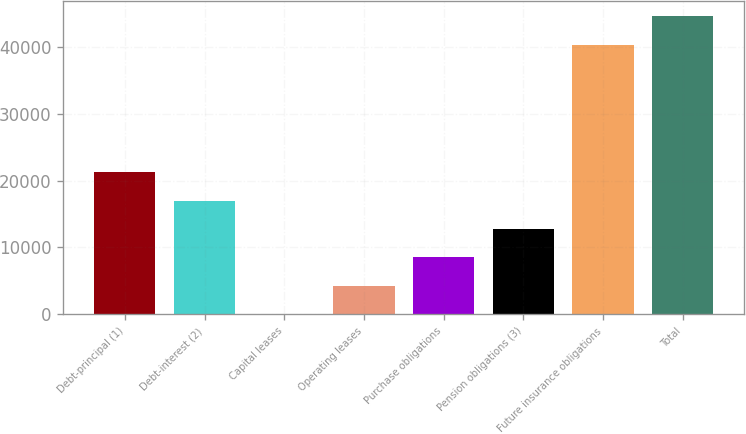<chart> <loc_0><loc_0><loc_500><loc_500><bar_chart><fcel>Debt-principal (1)<fcel>Debt-interest (2)<fcel>Capital leases<fcel>Operating leases<fcel>Purchase obligations<fcel>Pension obligations (3)<fcel>Future insurance obligations<fcel>Total<nl><fcel>21266.9<fcel>17014.1<fcel>2.83<fcel>4255.65<fcel>8508.47<fcel>12761.3<fcel>40332<fcel>44584.8<nl></chart> 